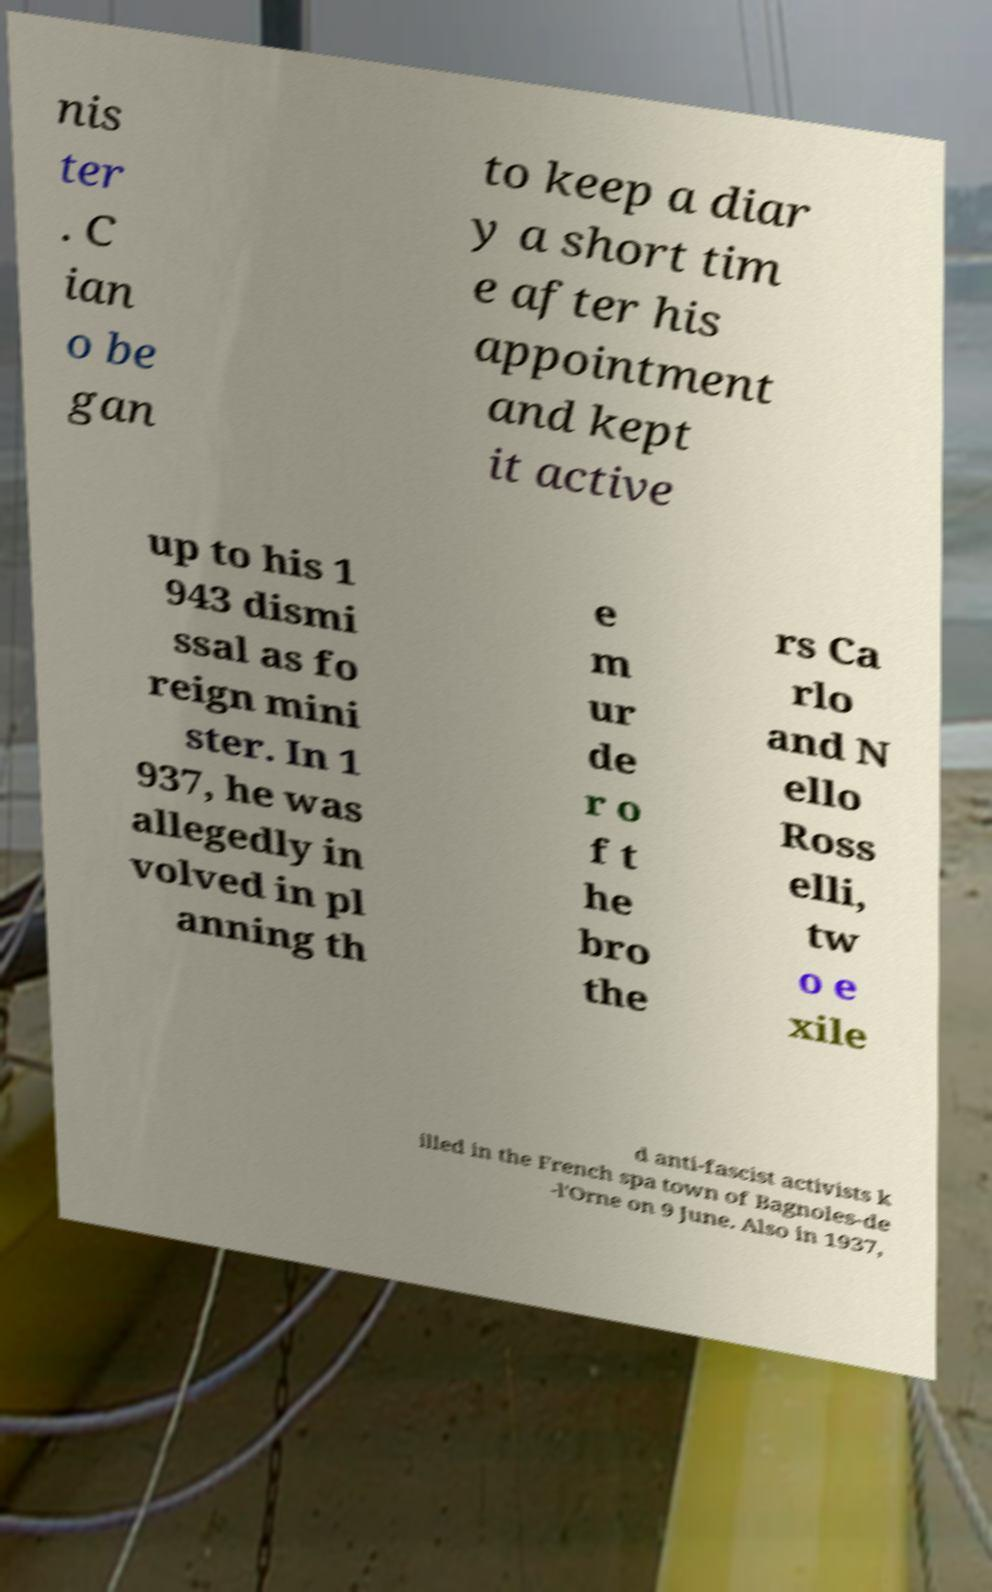Can you accurately transcribe the text from the provided image for me? nis ter . C ian o be gan to keep a diar y a short tim e after his appointment and kept it active up to his 1 943 dismi ssal as fo reign mini ster. In 1 937, he was allegedly in volved in pl anning th e m ur de r o f t he bro the rs Ca rlo and N ello Ross elli, tw o e xile d anti-fascist activists k illed in the French spa town of Bagnoles-de -l'Orne on 9 June. Also in 1937, 